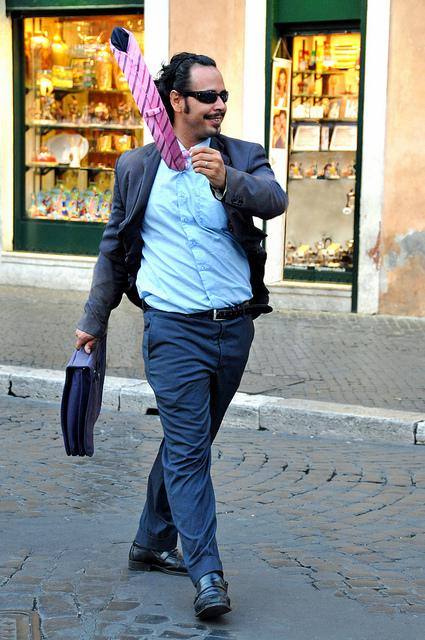What is this man experiencing?

Choices:
A) sleet
B) snow
C) rain
D) high wind high wind 